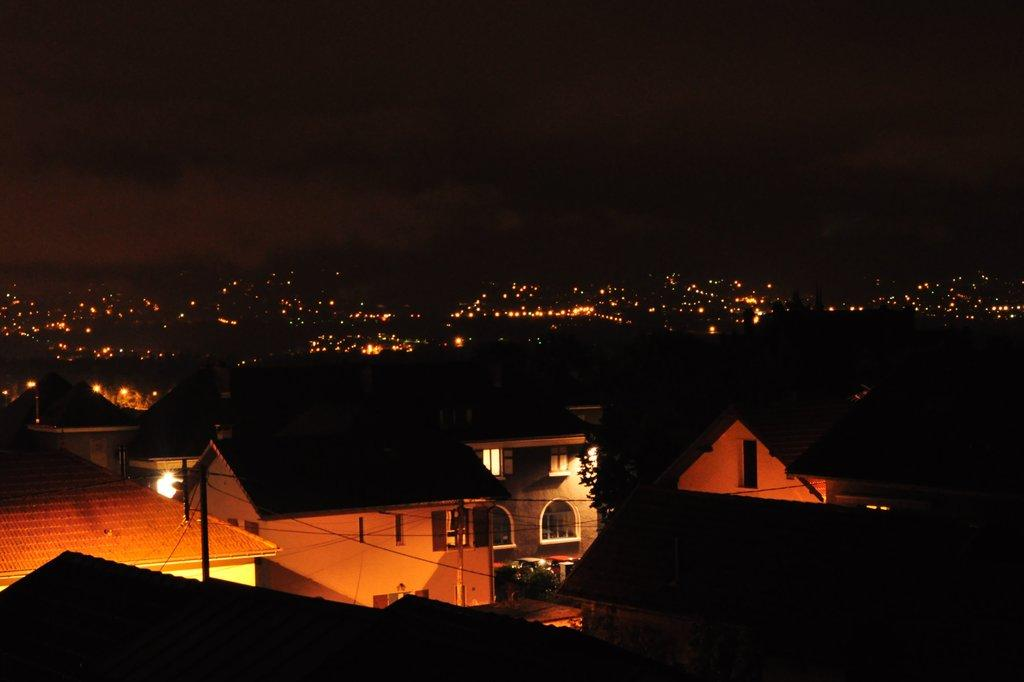What type of structures can be seen in the image? There are buildings in the image. What natural elements are present in the image? There are trees in the image. What man-made objects can be seen in the image? There are poles in the image. What is the purpose of the wires visible in the image? Current wires are visible in the image, which suggests they are used for transmitting electricity. What can be used for illumination in the image? Lights are present in the image. How would you describe the overall lighting in the image? The background of the image is dark. What type of paper is being used to write questions in the image? There is no paper or writing present in the image. How does the comfort of the chairs in the image affect the people sitting on them? There are no chairs or people present in the image, so it is impossible to determine the comfort level. 